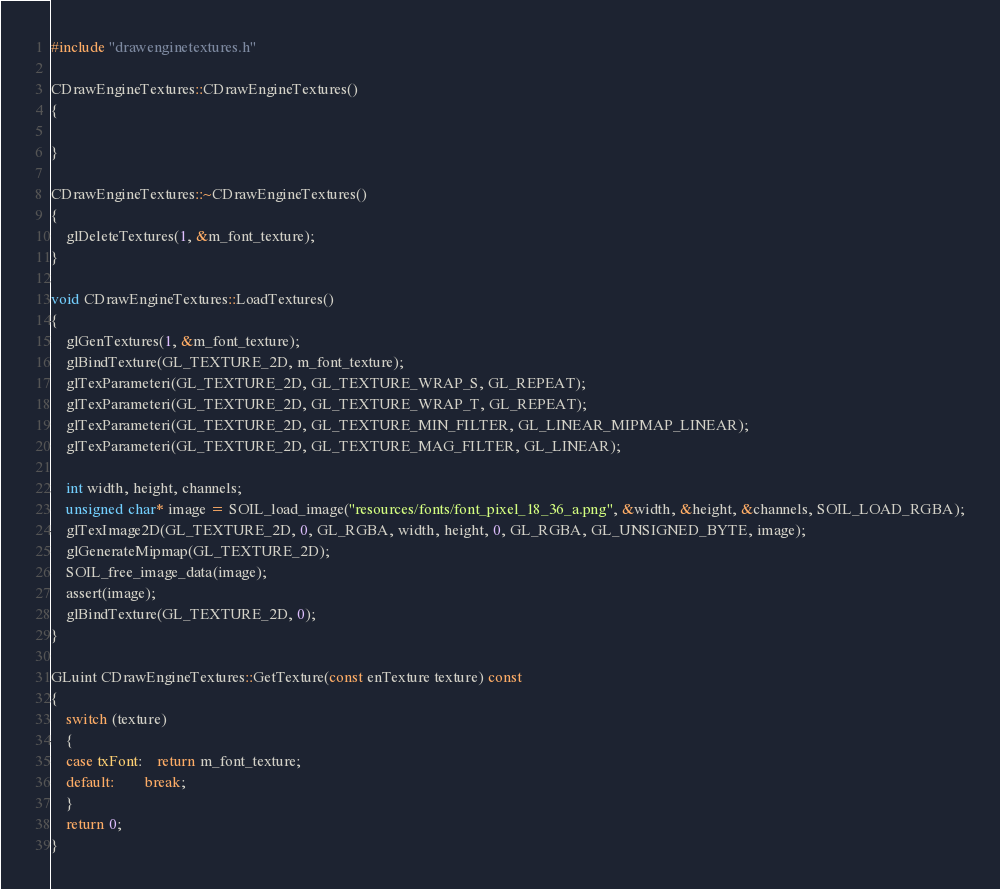<code> <loc_0><loc_0><loc_500><loc_500><_C++_>#include "drawenginetextures.h"

CDrawEngineTextures::CDrawEngineTextures()
{

}

CDrawEngineTextures::~CDrawEngineTextures()
{
    glDeleteTextures(1, &m_font_texture);
}

void CDrawEngineTextures::LoadTextures()
{
    glGenTextures(1, &m_font_texture);
    glBindTexture(GL_TEXTURE_2D, m_font_texture);
    glTexParameteri(GL_TEXTURE_2D, GL_TEXTURE_WRAP_S, GL_REPEAT);
    glTexParameteri(GL_TEXTURE_2D, GL_TEXTURE_WRAP_T, GL_REPEAT);
    glTexParameteri(GL_TEXTURE_2D, GL_TEXTURE_MIN_FILTER, GL_LINEAR_MIPMAP_LINEAR);
    glTexParameteri(GL_TEXTURE_2D, GL_TEXTURE_MAG_FILTER, GL_LINEAR);

    int width, height, channels;
    unsigned char* image = SOIL_load_image("resources/fonts/font_pixel_18_36_a.png", &width, &height, &channels, SOIL_LOAD_RGBA);
    glTexImage2D(GL_TEXTURE_2D, 0, GL_RGBA, width, height, 0, GL_RGBA, GL_UNSIGNED_BYTE, image);
    glGenerateMipmap(GL_TEXTURE_2D);
    SOIL_free_image_data(image);
    assert(image);
    glBindTexture(GL_TEXTURE_2D, 0);
}

GLuint CDrawEngineTextures::GetTexture(const enTexture texture) const
{
    switch (texture)
    {
    case txFont:    return m_font_texture;
    default:        break;
    }
    return 0;
}
</code> 